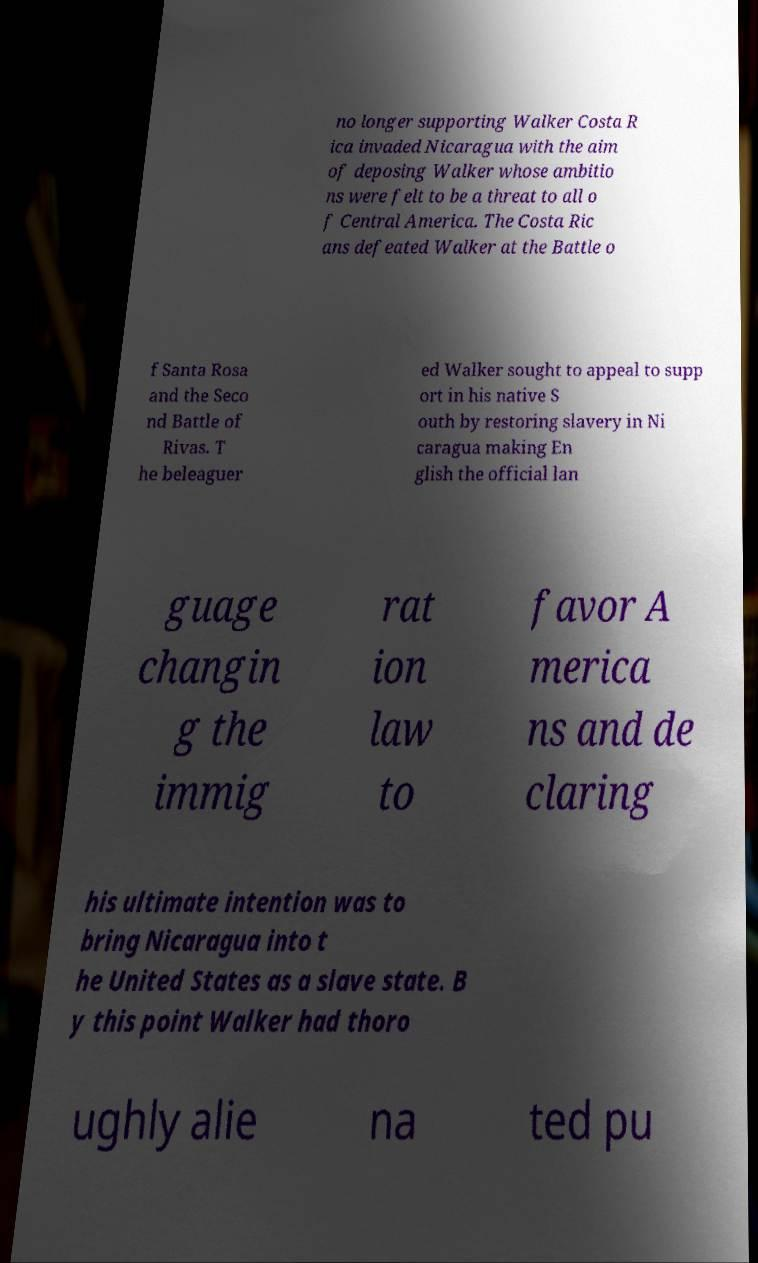Could you assist in decoding the text presented in this image and type it out clearly? no longer supporting Walker Costa R ica invaded Nicaragua with the aim of deposing Walker whose ambitio ns were felt to be a threat to all o f Central America. The Costa Ric ans defeated Walker at the Battle o f Santa Rosa and the Seco nd Battle of Rivas. T he beleaguer ed Walker sought to appeal to supp ort in his native S outh by restoring slavery in Ni caragua making En glish the official lan guage changin g the immig rat ion law to favor A merica ns and de claring his ultimate intention was to bring Nicaragua into t he United States as a slave state. B y this point Walker had thoro ughly alie na ted pu 